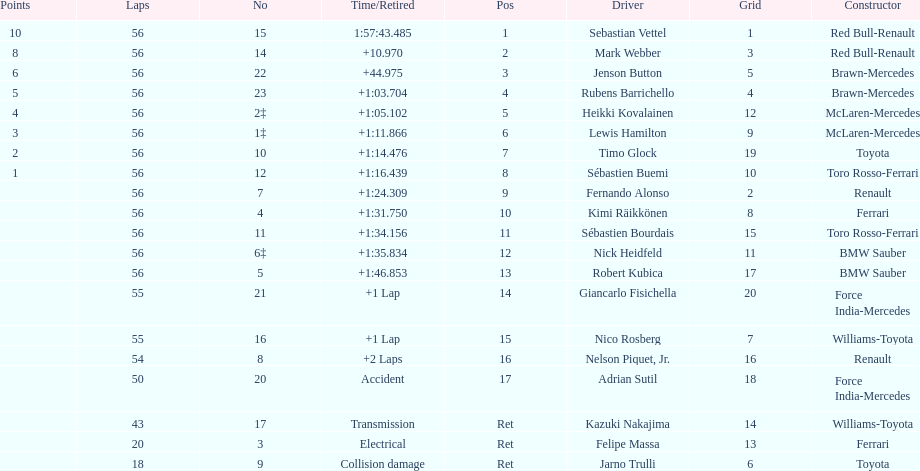What driver was last on the list? Jarno Trulli. 